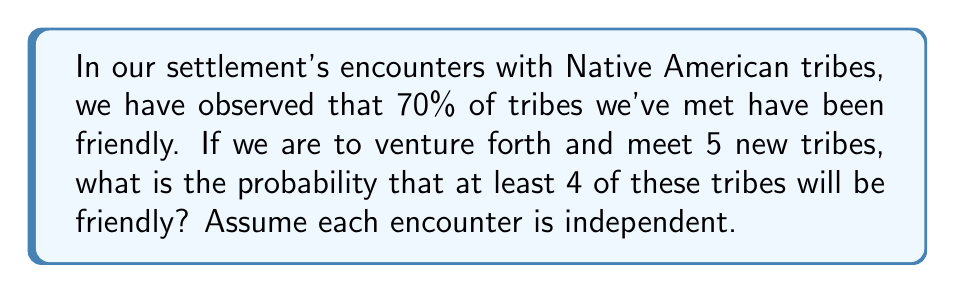Can you solve this math problem? To solve this problem, we shall use the Binomial distribution and Bayesian thinking.

1) Let $p = 0.7$ be the probability of a tribe being friendly based on our prior encounters.

2) We want to find $P(X \geq 4)$ where $X$ is the number of friendly tribes out of 5 encounters.

3) This is equivalent to $1 - P(X \leq 3)$

4) Using the Binomial distribution:

   $$P(X = k) = \binom{n}{k} p^k (1-p)^{n-k}$$

   where $n = 5$ (total encounters) and $k$ is the number of successes (friendly tribes).

5) We need to calculate:

   $$1 - [P(X = 0) + P(X = 1) + P(X = 2) + P(X = 3)]$$

6) Let's calculate each term:

   $P(X = 0) = \binom{5}{0} 0.7^0 (0.3)^5 = 0.00243$
   
   $P(X = 1) = \binom{5}{1} 0.7^1 (0.3)^4 = 0.02835$
   
   $P(X = 2) = \binom{5}{2} 0.7^2 (0.3)^3 = 0.13230$
   
   $P(X = 3) = \binom{5}{3} 0.7^3 (0.3)^2 = 0.30870$

7) Sum these probabilities:

   $P(X \leq 3) = 0.00243 + 0.02835 + 0.13230 + 0.30870 = 0.47178$

8) Therefore, $P(X \geq 4) = 1 - 0.47178 = 0.52822$
Answer: The probability of encountering at least 4 friendly tribes out of 5 new encounters is approximately 0.5282 or 52.82%. 